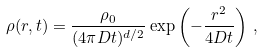Convert formula to latex. <formula><loc_0><loc_0><loc_500><loc_500>\rho ( r , t ) = \frac { \rho _ { 0 } } { ( 4 \pi D t ) ^ { d / 2 } } \exp \left ( - \frac { r ^ { 2 } } { 4 D t } \right ) \, ,</formula> 